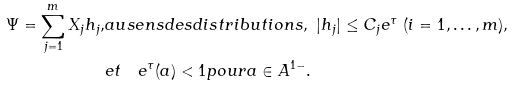<formula> <loc_0><loc_0><loc_500><loc_500>\Psi = \sum _ { j = 1 } ^ { m } X _ { j } h _ { j } , & a u s e n s d e s d i s t r i b u t i o n s , \ | h _ { j } | \leq C _ { j } e ^ { \tau } \ ( i = 1 , \dots , m ) , \\ & e t \quad e ^ { \tau } ( a ) < 1 p o u r a \in A ^ { 1 - } .</formula> 